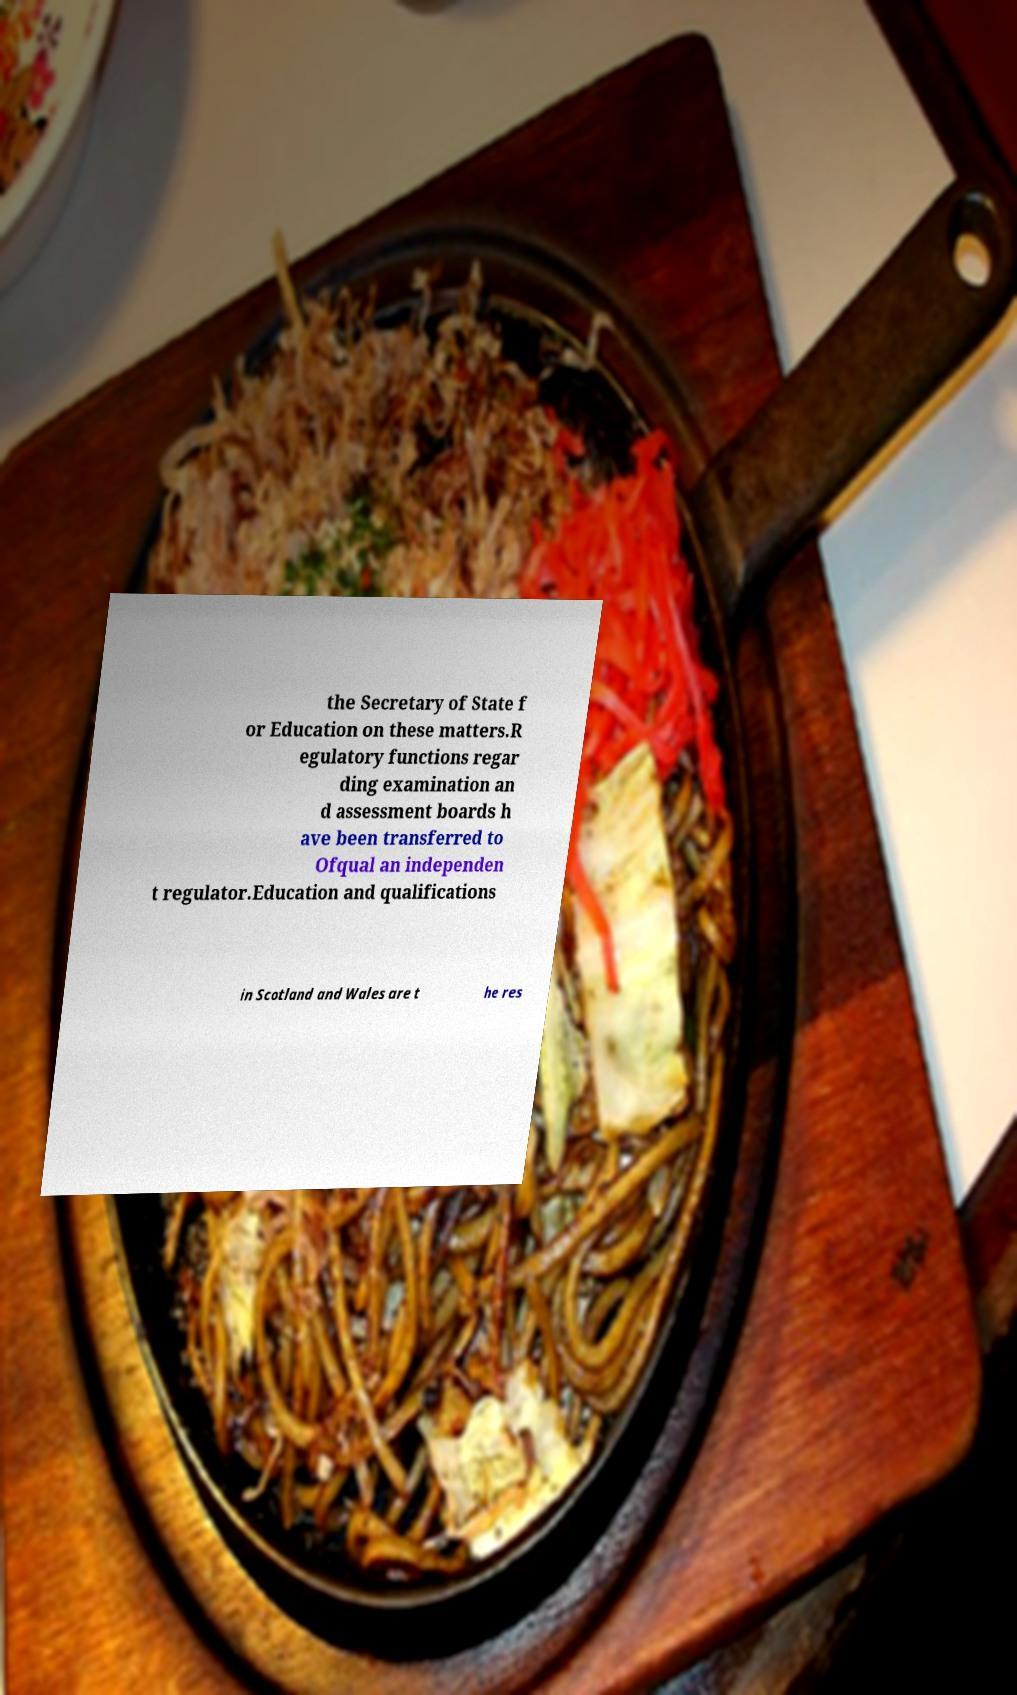Please identify and transcribe the text found in this image. the Secretary of State f or Education on these matters.R egulatory functions regar ding examination an d assessment boards h ave been transferred to Ofqual an independen t regulator.Education and qualifications in Scotland and Wales are t he res 